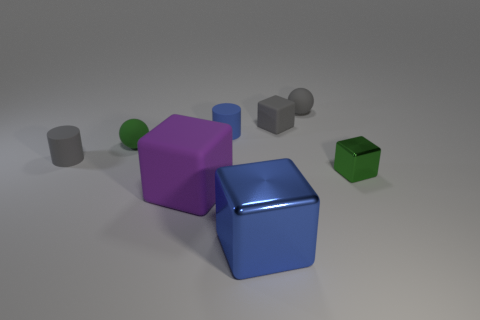Do the small cube left of the small metal thing and the purple cube have the same material?
Offer a terse response. Yes. What is the shape of the tiny object that is in front of the tiny green rubber object and to the right of the big purple rubber object?
Your answer should be very brief. Cube. There is a large cube to the right of the purple block; are there any large shiny blocks right of it?
Ensure brevity in your answer.  No. How many other objects are there of the same material as the large purple cube?
Ensure brevity in your answer.  5. There is a green thing on the left side of the small metallic thing; is it the same shape as the blue object in front of the tiny blue rubber object?
Your response must be concise. No. Is the material of the blue cylinder the same as the large purple cube?
Give a very brief answer. Yes. What size is the ball on the right side of the big object that is behind the blue object that is in front of the blue matte cylinder?
Offer a terse response. Small. What number of other things are the same color as the tiny matte block?
Offer a terse response. 2. What shape is the green shiny thing that is the same size as the blue cylinder?
Provide a short and direct response. Cube. How many small things are either matte spheres or matte cylinders?
Your answer should be compact. 4. 